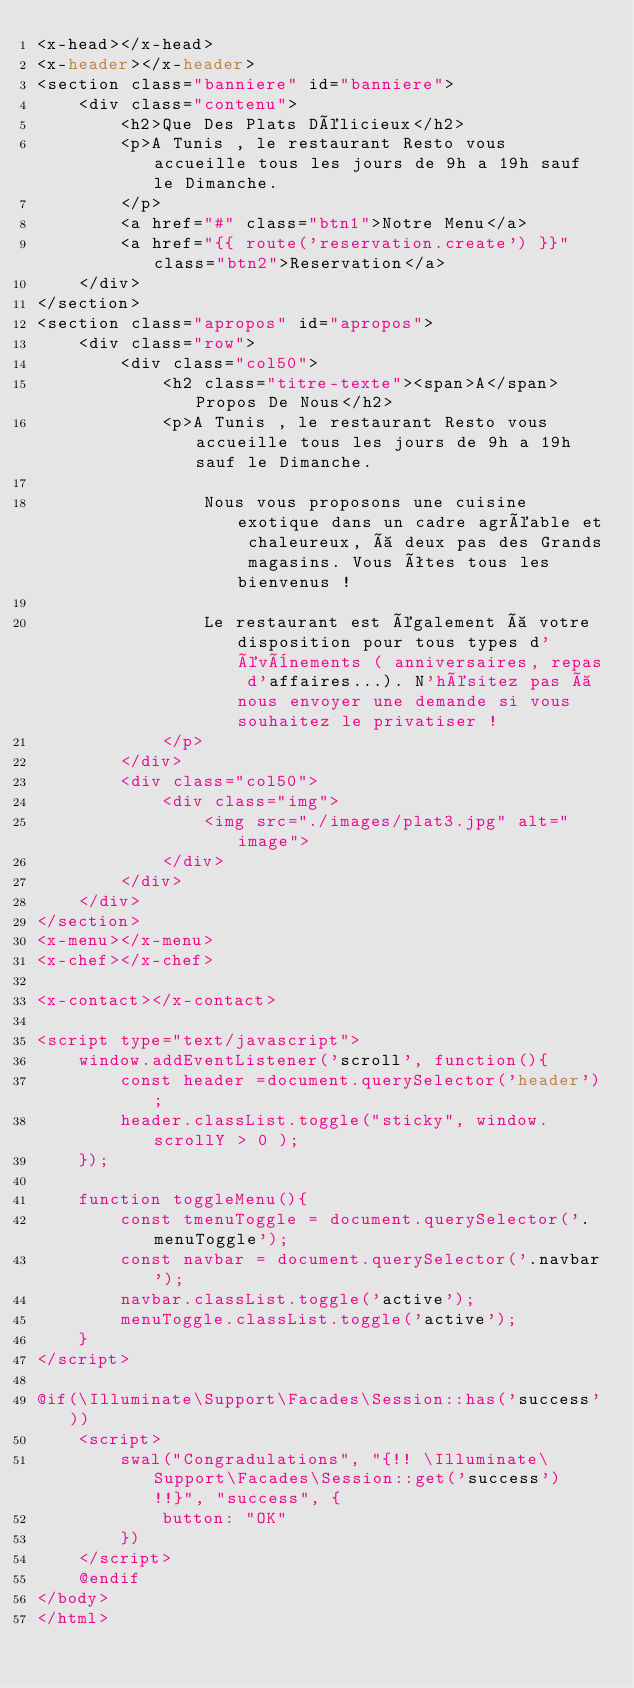Convert code to text. <code><loc_0><loc_0><loc_500><loc_500><_PHP_><x-head></x-head>
<x-header></x-header>
<section class="banniere" id="banniere">
    <div class="contenu">
        <h2>Que Des Plats Délicieux</h2>
        <p>A Tunis , le restaurant Resto vous accueille tous les jours de 9h a 19h sauf le Dimanche.
        </p>
        <a href="#" class="btn1">Notre Menu</a>
        <a href="{{ route('reservation.create') }}" class="btn2">Reservation</a>
    </div>
</section>
<section class="apropos" id="apropos">
    <div class="row">
        <div class="col50">
            <h2 class="titre-texte"><span>A</span> Propos De Nous</h2>
            <p>A Tunis , le restaurant Resto vous accueille tous les jours de 9h a 19h sauf le Dimanche.

                Nous vous proposons une cuisine exotique dans un cadre agréable et chaleureux, à deux pas des Grands magasins. Vous êtes tous les bienvenus !

                Le restaurant est également à votre disposition pour tous types d'évènements ( anniversaires, repas d'affaires...). N'hésitez pas à nous envoyer une demande si vous souhaitez le privatiser !
            </p>
        </div>
        <div class="col50">
            <div class="img">
                <img src="./images/plat3.jpg" alt="image">
            </div>
        </div>
    </div>
</section>
<x-menu></x-menu>
<x-chef></x-chef>

<x-contact></x-contact>

<script type="text/javascript">
    window.addEventListener('scroll', function(){
        const header =document.querySelector('header');
        header.classList.toggle("sticky", window.scrollY > 0 );
    });

    function toggleMenu(){
        const tmenuToggle = document.querySelector('.menuToggle');
        const navbar = document.querySelector('.navbar');
        navbar.classList.toggle('active');
        menuToggle.classList.toggle('active');
    }
</script>

@if(\Illuminate\Support\Facades\Session::has('success'))
    <script>
        swal("Congradulations", "{!! \Illuminate\Support\Facades\Session::get('success') !!}", "success", {
            button: "OK"
        })
    </script>
    @endif
</body>
</html>
</code> 